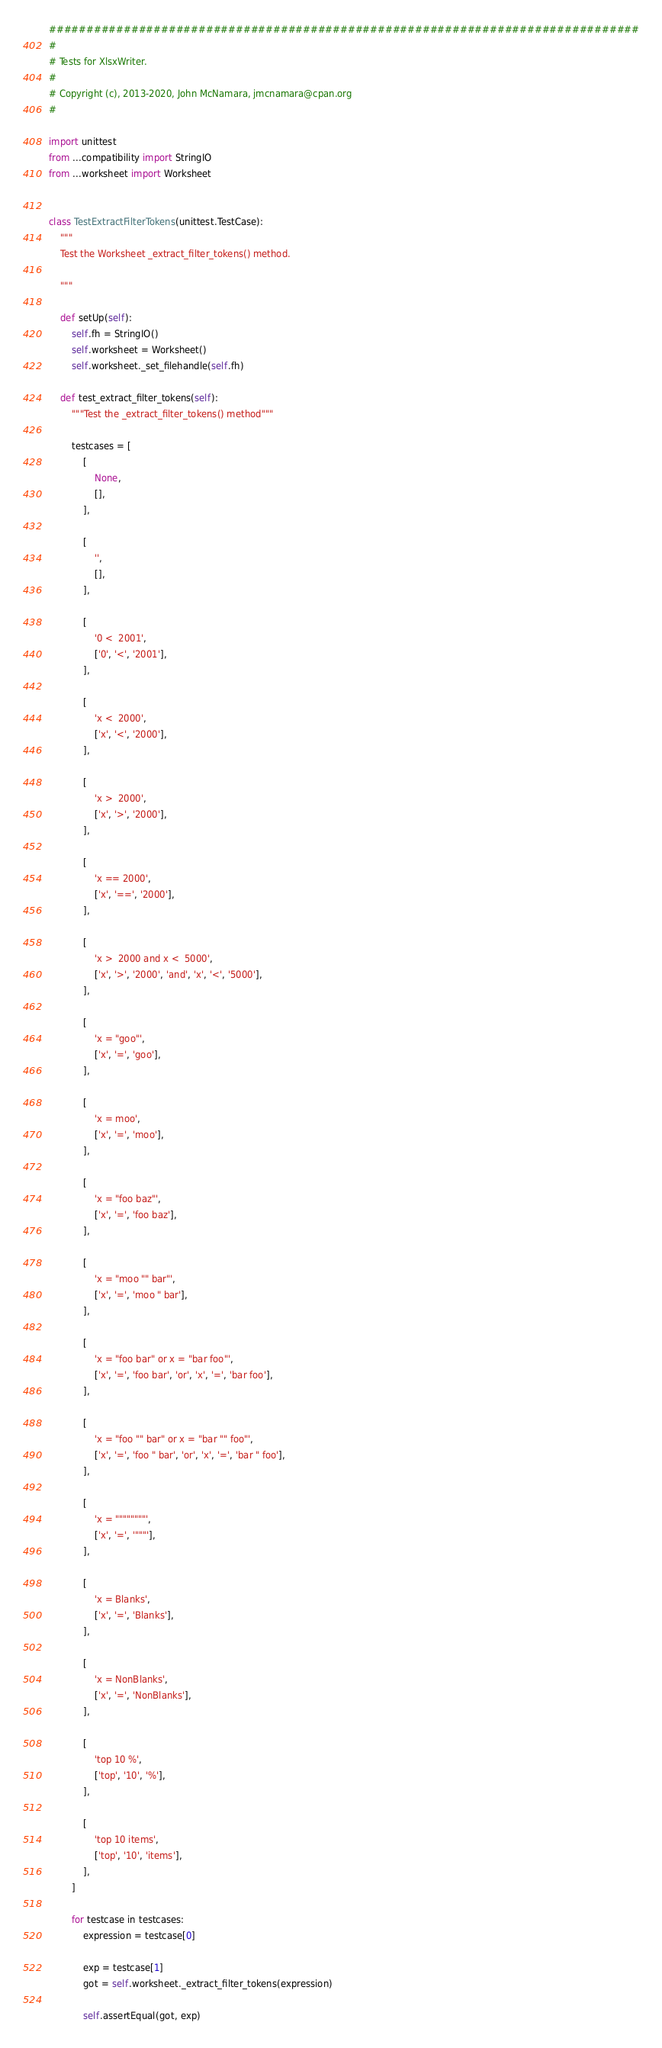<code> <loc_0><loc_0><loc_500><loc_500><_Python_>###############################################################################
#
# Tests for XlsxWriter.
#
# Copyright (c), 2013-2020, John McNamara, jmcnamara@cpan.org
#

import unittest
from ...compatibility import StringIO
from ...worksheet import Worksheet


class TestExtractFilterTokens(unittest.TestCase):
    """
    Test the Worksheet _extract_filter_tokens() method.

    """

    def setUp(self):
        self.fh = StringIO()
        self.worksheet = Worksheet()
        self.worksheet._set_filehandle(self.fh)

    def test_extract_filter_tokens(self):
        """Test the _extract_filter_tokens() method"""

        testcases = [
            [
                None,
                [],
            ],

            [
                '',
                [],
            ],

            [
                '0 <  2001',
                ['0', '<', '2001'],
            ],

            [
                'x <  2000',
                ['x', '<', '2000'],
            ],

            [
                'x >  2000',
                ['x', '>', '2000'],
            ],

            [
                'x == 2000',
                ['x', '==', '2000'],
            ],

            [
                'x >  2000 and x <  5000',
                ['x', '>', '2000', 'and', 'x', '<', '5000'],
            ],

            [
                'x = "goo"',
                ['x', '=', 'goo'],
            ],

            [
                'x = moo',
                ['x', '=', 'moo'],
            ],

            [
                'x = "foo baz"',
                ['x', '=', 'foo baz'],
            ],

            [
                'x = "moo "" bar"',
                ['x', '=', 'moo " bar'],
            ],

            [
                'x = "foo bar" or x = "bar foo"',
                ['x', '=', 'foo bar', 'or', 'x', '=', 'bar foo'],
            ],

            [
                'x = "foo "" bar" or x = "bar "" foo"',
                ['x', '=', 'foo " bar', 'or', 'x', '=', 'bar " foo'],
            ],

            [
                'x = """"""""',
                ['x', '=', '"""'],
            ],

            [
                'x = Blanks',
                ['x', '=', 'Blanks'],
            ],

            [
                'x = NonBlanks',
                ['x', '=', 'NonBlanks'],
            ],

            [
                'top 10 %',
                ['top', '10', '%'],
            ],

            [
                'top 10 items',
                ['top', '10', 'items'],
            ],
        ]

        for testcase in testcases:
            expression = testcase[0]

            exp = testcase[1]
            got = self.worksheet._extract_filter_tokens(expression)

            self.assertEqual(got, exp)
</code> 